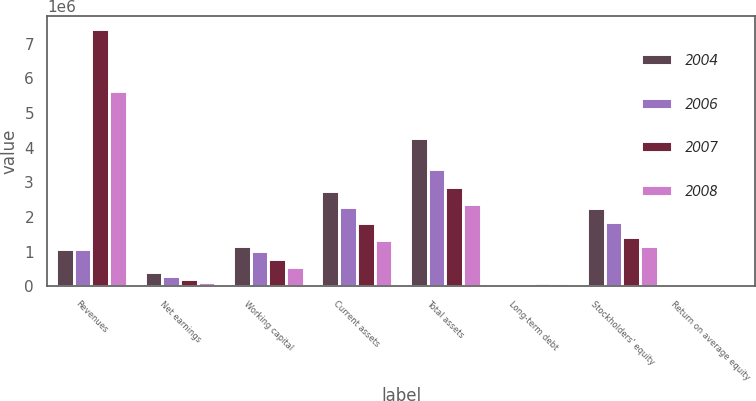Convert chart to OTSL. <chart><loc_0><loc_0><loc_500><loc_500><stacked_bar_chart><ecel><fcel>Revenues<fcel>Net earnings<fcel>Working capital<fcel>Current assets<fcel>Total assets<fcel>Long-term debt<fcel>Stockholders' equity<fcel>Return on average equity<nl><fcel>2004<fcel>1.08371e+06<fcel>420742<fcel>1.17324e+06<fcel>2.75023e+06<fcel>4.27824e+06<fcel>55675<fcel>2.24515e+06<fcel>20.58<nl><fcel>2006<fcel>1.08371e+06<fcel>287130<fcel>1.00164e+06<fcel>2.27808e+06<fcel>3.38942e+06<fcel>40450<fcel>1.84366e+06<fcel>17.58<nl><fcel>2007<fcel>7.42127e+06<fcel>196883<fcel>776766<fcel>1.81796e+06<fcel>2.85388e+06<fcel>77673<fcel>1.42321e+06<fcel>15.21<nl><fcel>2008<fcel>5.635e+06<fcel>131608<fcel>552336<fcel>1.33743e+06<fcel>2.37886e+06<fcel>89632<fcel>1.16578e+06<fcel>12<nl></chart> 